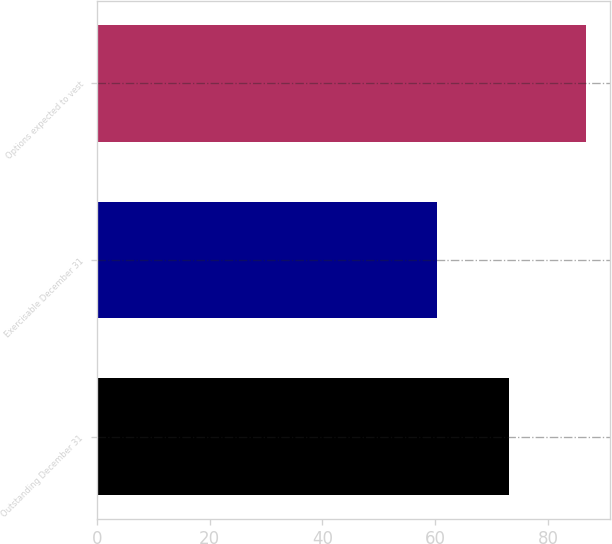<chart> <loc_0><loc_0><loc_500><loc_500><bar_chart><fcel>Outstanding December 31<fcel>Exercisable December 31<fcel>Options expected to vest<nl><fcel>73.14<fcel>60.3<fcel>86.75<nl></chart> 